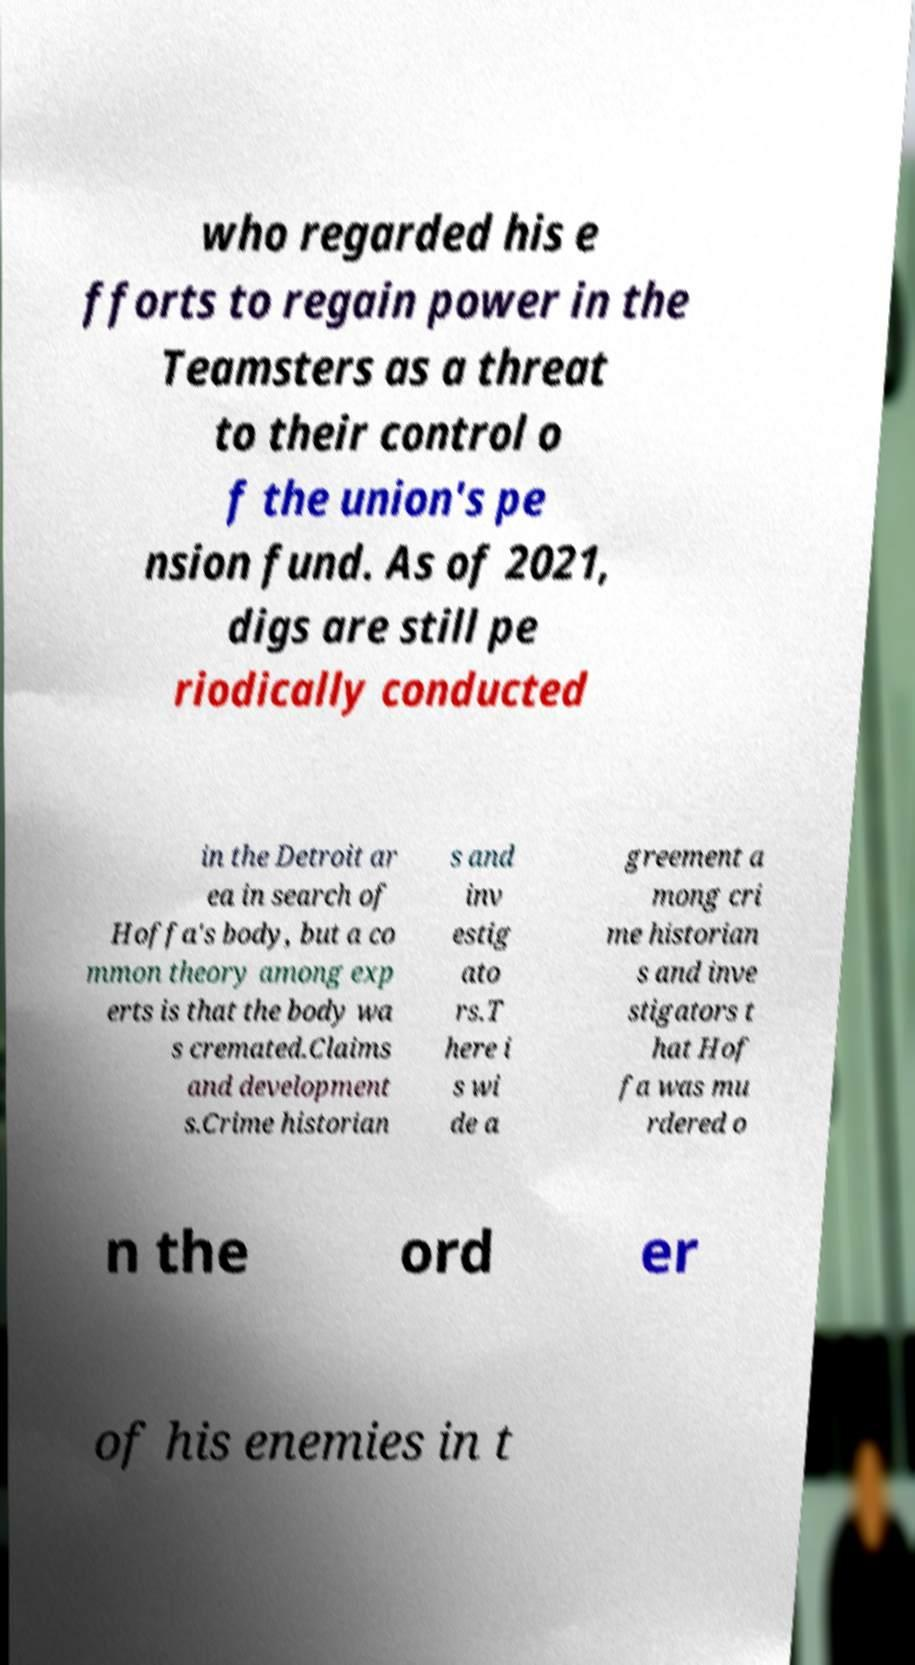Please identify and transcribe the text found in this image. who regarded his e fforts to regain power in the Teamsters as a threat to their control o f the union's pe nsion fund. As of 2021, digs are still pe riodically conducted in the Detroit ar ea in search of Hoffa's body, but a co mmon theory among exp erts is that the body wa s cremated.Claims and development s.Crime historian s and inv estig ato rs.T here i s wi de a greement a mong cri me historian s and inve stigators t hat Hof fa was mu rdered o n the ord er of his enemies in t 